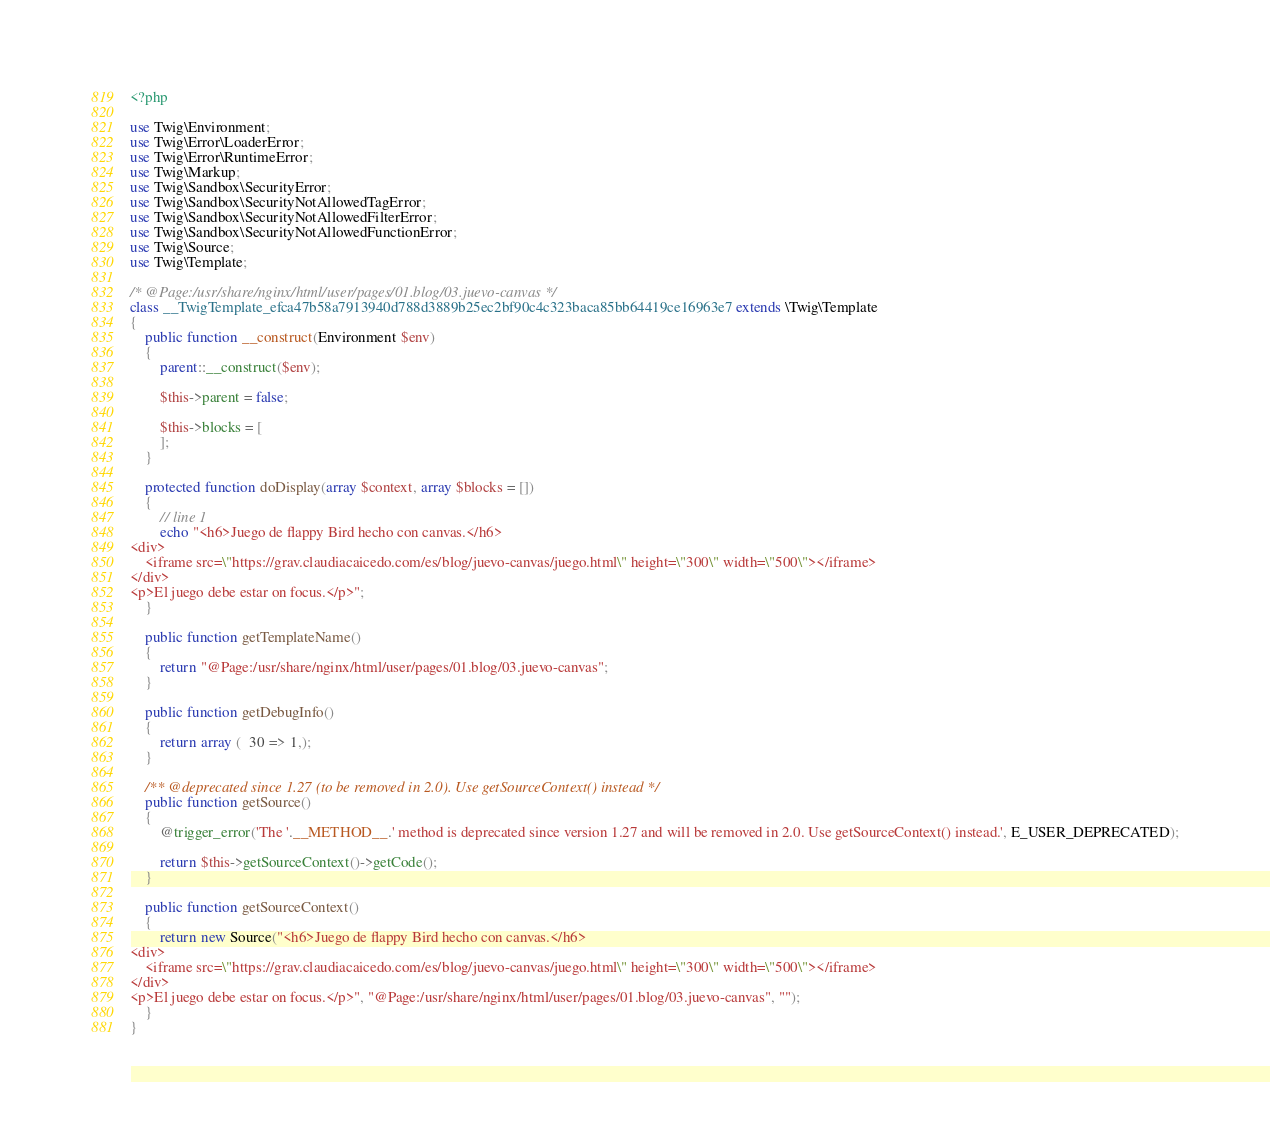<code> <loc_0><loc_0><loc_500><loc_500><_PHP_><?php

use Twig\Environment;
use Twig\Error\LoaderError;
use Twig\Error\RuntimeError;
use Twig\Markup;
use Twig\Sandbox\SecurityError;
use Twig\Sandbox\SecurityNotAllowedTagError;
use Twig\Sandbox\SecurityNotAllowedFilterError;
use Twig\Sandbox\SecurityNotAllowedFunctionError;
use Twig\Source;
use Twig\Template;

/* @Page:/usr/share/nginx/html/user/pages/01.blog/03.juevo-canvas */
class __TwigTemplate_efca47b58a7913940d788d3889b25ec2bf90c4c323baca85bb64419ce16963e7 extends \Twig\Template
{
    public function __construct(Environment $env)
    {
        parent::__construct($env);

        $this->parent = false;

        $this->blocks = [
        ];
    }

    protected function doDisplay(array $context, array $blocks = [])
    {
        // line 1
        echo "<h6>Juego de flappy Bird hecho con canvas.</h6>
<div>
    <iframe src=\"https://grav.claudiacaicedo.com/es/blog/juevo-canvas/juego.html\" height=\"300\" width=\"500\"></iframe>
</div>
<p>El juego debe estar on focus.</p>";
    }

    public function getTemplateName()
    {
        return "@Page:/usr/share/nginx/html/user/pages/01.blog/03.juevo-canvas";
    }

    public function getDebugInfo()
    {
        return array (  30 => 1,);
    }

    /** @deprecated since 1.27 (to be removed in 2.0). Use getSourceContext() instead */
    public function getSource()
    {
        @trigger_error('The '.__METHOD__.' method is deprecated since version 1.27 and will be removed in 2.0. Use getSourceContext() instead.', E_USER_DEPRECATED);

        return $this->getSourceContext()->getCode();
    }

    public function getSourceContext()
    {
        return new Source("<h6>Juego de flappy Bird hecho con canvas.</h6>
<div>
    <iframe src=\"https://grav.claudiacaicedo.com/es/blog/juevo-canvas/juego.html\" height=\"300\" width=\"500\"></iframe>
</div>
<p>El juego debe estar on focus.</p>", "@Page:/usr/share/nginx/html/user/pages/01.blog/03.juevo-canvas", "");
    }
}
</code> 